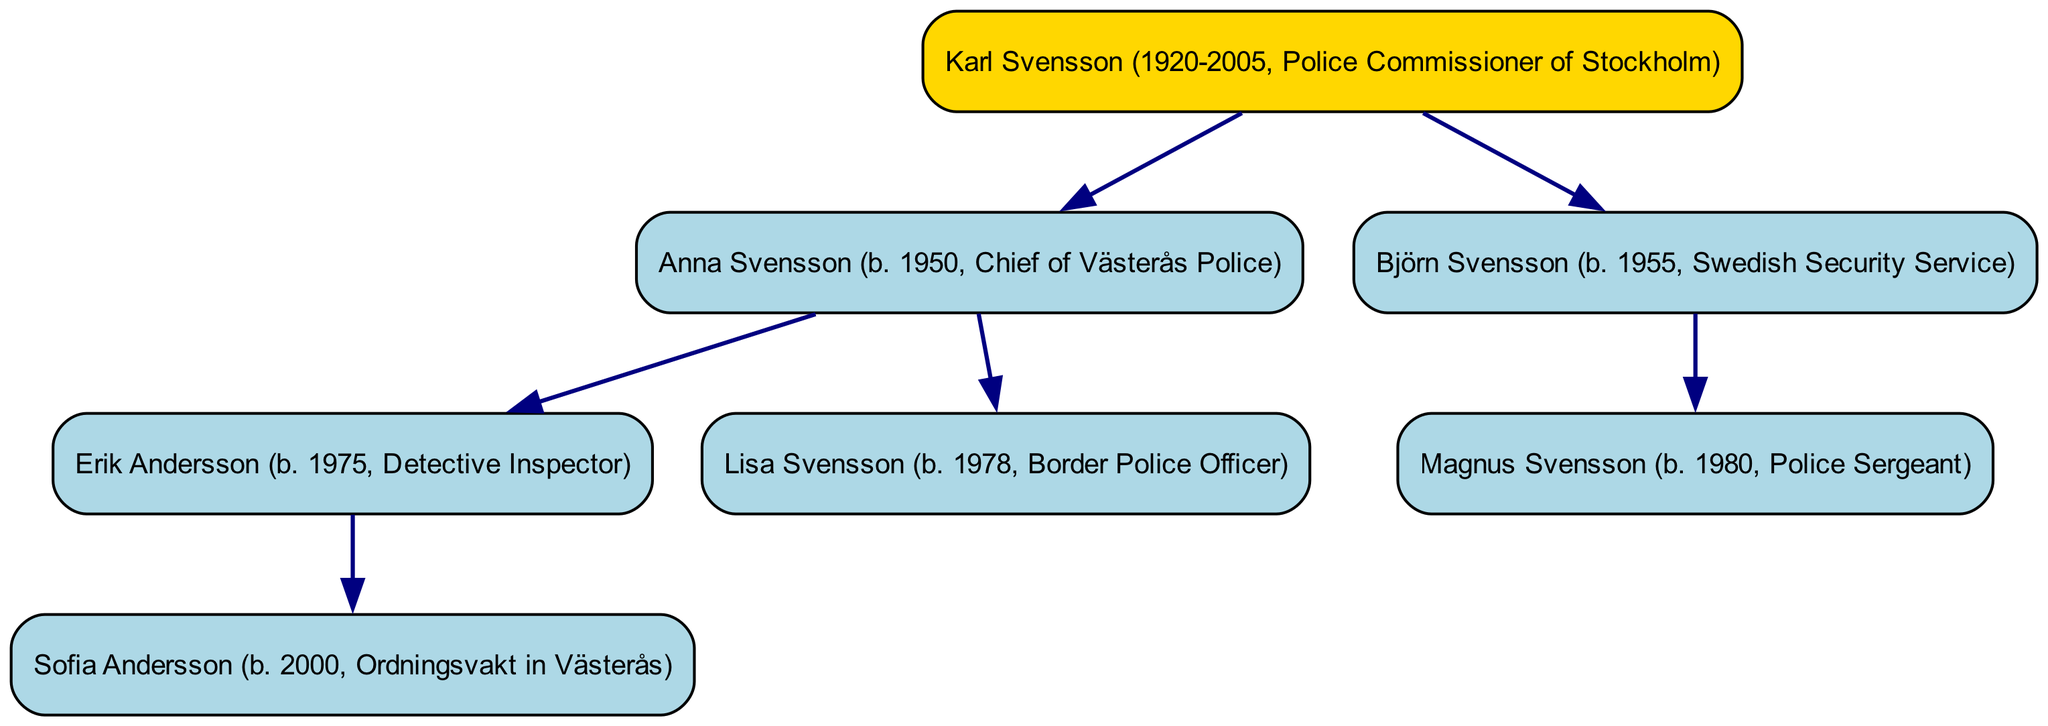What is the name of the root person in the family tree? The root person is listed at the top of the family tree, which indicates that they are the founding member or the most senior individual in the hierarchy. In this case, the root person is "Karl Svensson."
Answer: Karl Svensson Who is the Chief of Västerås Police? Looking at the hierarchy, Anna Svensson is listed as a child of the root person and is described as the Chief of Västerås Police, which provides direct information about her role.
Answer: Anna Svensson How many children does Karl Svensson have? By counting the immediate descendants connected to the root person in the family tree, we can see that Karl Svensson has two children: Anna Svensson and Björn Svensson.
Answer: 2 What profession does Sofia Andersson have? Sofia Andersson is the only child of Erik Andersson, and her profession is noted alongside her name in the diagram. Therefore, her occupation is "Ordningsvakt in Västerås."
Answer: Ordningsvakt in Västerås Who is the eldest child of Karl Svensson? To determine the eldest child, we review the birth years of both children of Karl Svensson. Anna was born in 1950 and Björn in 1955, which indicates that Anna is older.
Answer: Anna Svensson How many total generations are represented in the family tree? The diagram displays three distinct levels: the root generation (Karl Svensson), his children's generation (Anna and Björn), and his grandchildren's generation (Erik, Lisa, and Magnus, along with Sofia). Therefore, there are three generations.
Answer: 3 Which officer is listed as a Border Police Officer? Examining the children of Anna Svensson, we find that Lisa Svensson is specifically mentioned as a Border Police Officer, making her the individual we are looking for.
Answer: Lisa Svensson Who are the descendants of Anna Svensson? Anna Svensson has two children, Erik and Lisa, represented in the family tree, thus making them her descendants.
Answer: Erik Andersson and Lisa Svensson What is the profession of Magnus Svensson? By reviewing the details concerning Björn Svensson's child, we find that Magnus Svensson is identified as a "Police Sergeant," which directly answers the question about his profession.
Answer: Police Sergeant 